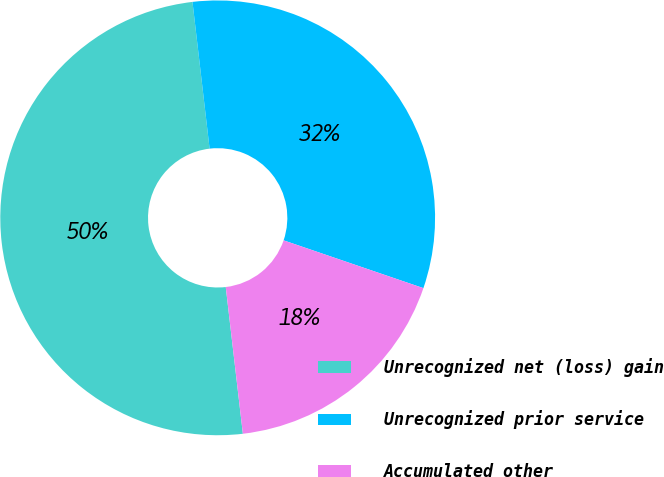Convert chart to OTSL. <chart><loc_0><loc_0><loc_500><loc_500><pie_chart><fcel>Unrecognized net (loss) gain<fcel>Unrecognized prior service<fcel>Accumulated other<nl><fcel>50.0%<fcel>32.09%<fcel>17.91%<nl></chart> 